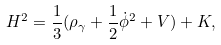<formula> <loc_0><loc_0><loc_500><loc_500>H ^ { 2 } = \frac { 1 } { 3 } ( \rho _ { \gamma } + \frac { 1 } { 2 } \dot { \phi } ^ { 2 } + V ) + K ,</formula> 